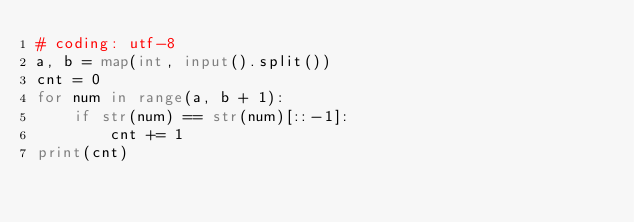<code> <loc_0><loc_0><loc_500><loc_500><_Python_># coding: utf-8
a, b = map(int, input().split())
cnt = 0
for num in range(a, b + 1):
    if str(num) == str(num)[::-1]:
        cnt += 1
print(cnt)</code> 